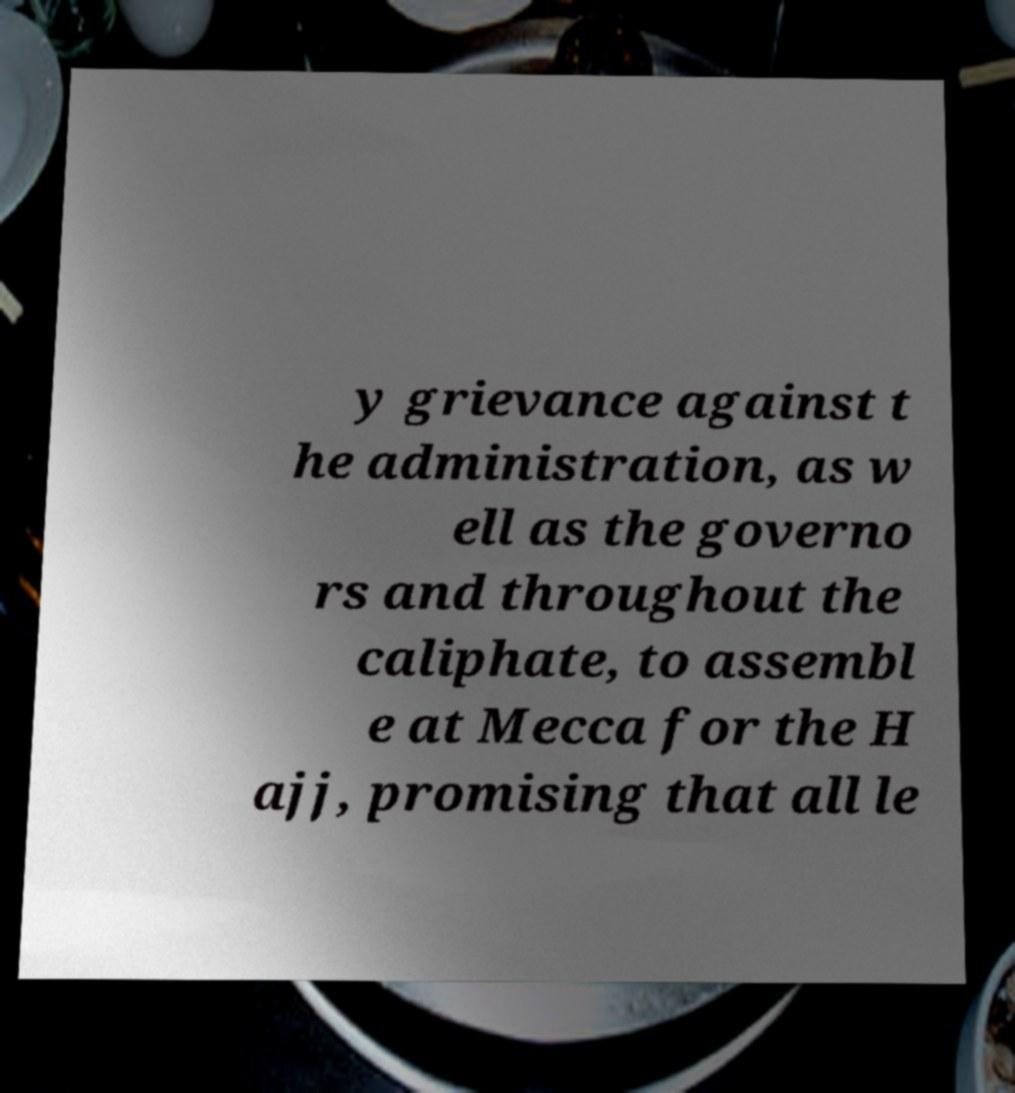Please read and relay the text visible in this image. What does it say? y grievance against t he administration, as w ell as the governo rs and throughout the caliphate, to assembl e at Mecca for the H ajj, promising that all le 